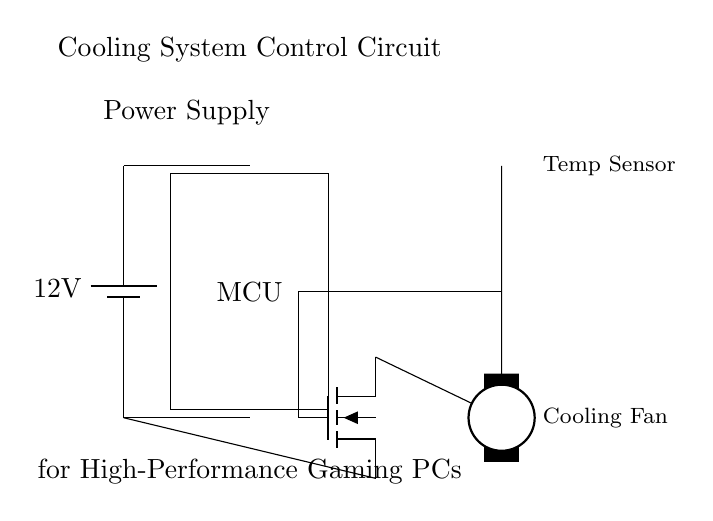What is the power supply voltage? The power supply voltage is 12 volts, as indicated by the battery symbol in the circuit diagram.
Answer: 12 volts What is the function of the MCU in this circuit? The MCU acts as the control unit that processes inputs from the temperature sensor and controls the cooling fan according to the measured temperature.
Answer: Control unit How many fans are depicted in the circuit? There is one cooling fan shown in the circuit, represented by the elmech symbol at the bottom right.
Answer: One What component is used to switch the fan on and off? The component used to switch the fan is the MOSFET, which is indicated by the nfet symbol in the circuit and connects the fan to the ground.
Answer: MOSFET How does the temperature sensor communicate with the MCU? The temperature sensor communicates with the MCU through a direct connection, allowing the MCU to receive temperature data to control the fan's operation.
Answer: Direct connection What is the role of the cooling fan in the circuit? The cooling fan helps to dissipate heat generated by the high-performance gaming PC, ensuring optimal performance and preventing overheating.
Answer: Dissipate heat What is the relationship between the MCU and the MOSFET in this circuit? The MCU sends a control signal to the gate of the MOSFET, which turns on or off the MOSFET, thus controlling the operation of the cooling fan based on temperature readings.
Answer: Control signal relationship 